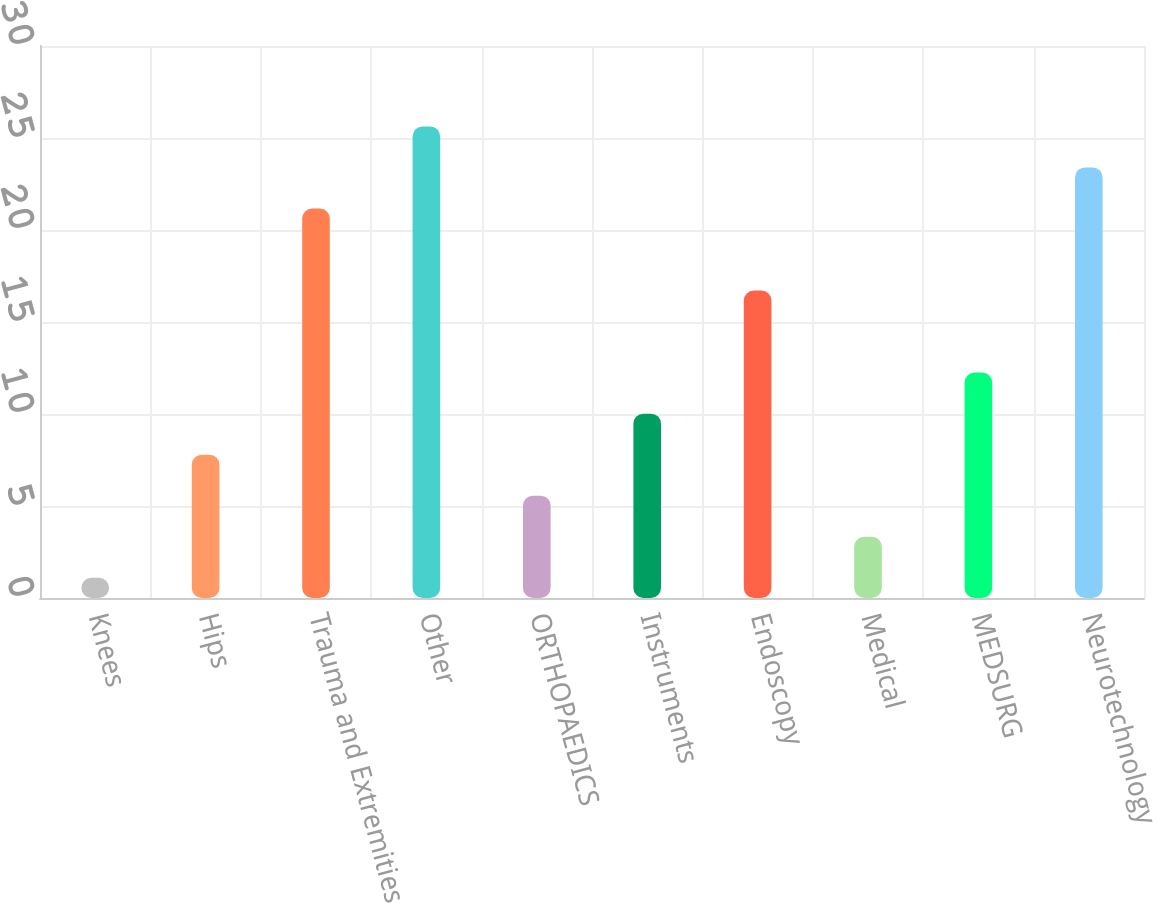Convert chart to OTSL. <chart><loc_0><loc_0><loc_500><loc_500><bar_chart><fcel>Knees<fcel>Hips<fcel>Trauma and Extremities<fcel>Other<fcel>ORTHOPAEDICS<fcel>Instruments<fcel>Endoscopy<fcel>Medical<fcel>MEDSURG<fcel>Neurotechnology<nl><fcel>1.1<fcel>7.79<fcel>21.17<fcel>25.63<fcel>5.56<fcel>10.02<fcel>16.71<fcel>3.33<fcel>12.25<fcel>23.4<nl></chart> 